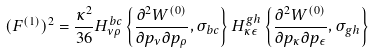Convert formula to latex. <formula><loc_0><loc_0><loc_500><loc_500>( F ^ { ( 1 ) } ) ^ { 2 } = \frac { \kappa ^ { 2 } } { 3 6 } H _ { \nu \rho } ^ { b c } \left \{ \frac { \partial ^ { 2 } W ^ { ( 0 ) } } { \partial p _ { \nu } \partial p _ { \rho } } , \sigma _ { b c } \right \} H _ { \kappa \epsilon } ^ { g h } \left \{ \frac { \partial ^ { 2 } W ^ { ( 0 ) } } { \partial p _ { \kappa } \partial p _ { \epsilon } } , \sigma _ { g h } \right \}</formula> 